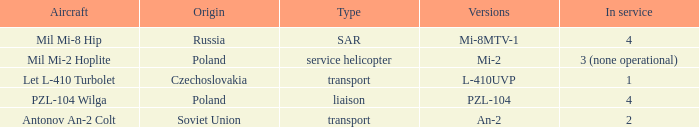Parse the full table. {'header': ['Aircraft', 'Origin', 'Type', 'Versions', 'In service'], 'rows': [['Mil Mi-8 Hip', 'Russia', 'SAR', 'Mi-8MTV-1', '4'], ['Mil Mi-2 Hoplite', 'Poland', 'service helicopter', 'Mi-2', '3 (none operational)'], ['Let L-410 Turbolet', 'Czechoslovakia', 'transport', 'L-410UVP', '1'], ['PZL-104 Wilga', 'Poland', 'liaison', 'PZL-104', '4'], ['Antonov An-2 Colt', 'Soviet Union', 'transport', 'An-2', '2']]} Tell me the aircraft for pzl-104 PZL-104 Wilga. 